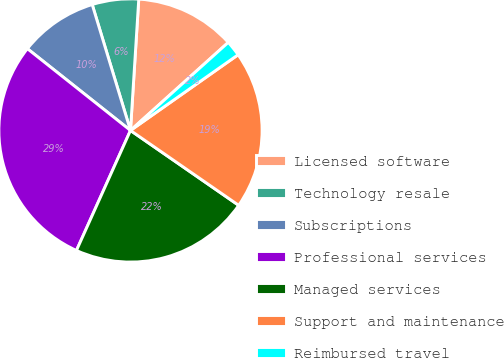<chart> <loc_0><loc_0><loc_500><loc_500><pie_chart><fcel>Licensed software<fcel>Technology resale<fcel>Subscriptions<fcel>Professional services<fcel>Managed services<fcel>Support and maintenance<fcel>Reimbursed travel<nl><fcel>12.33%<fcel>5.7%<fcel>9.63%<fcel>28.94%<fcel>22.1%<fcel>19.39%<fcel>1.91%<nl></chart> 